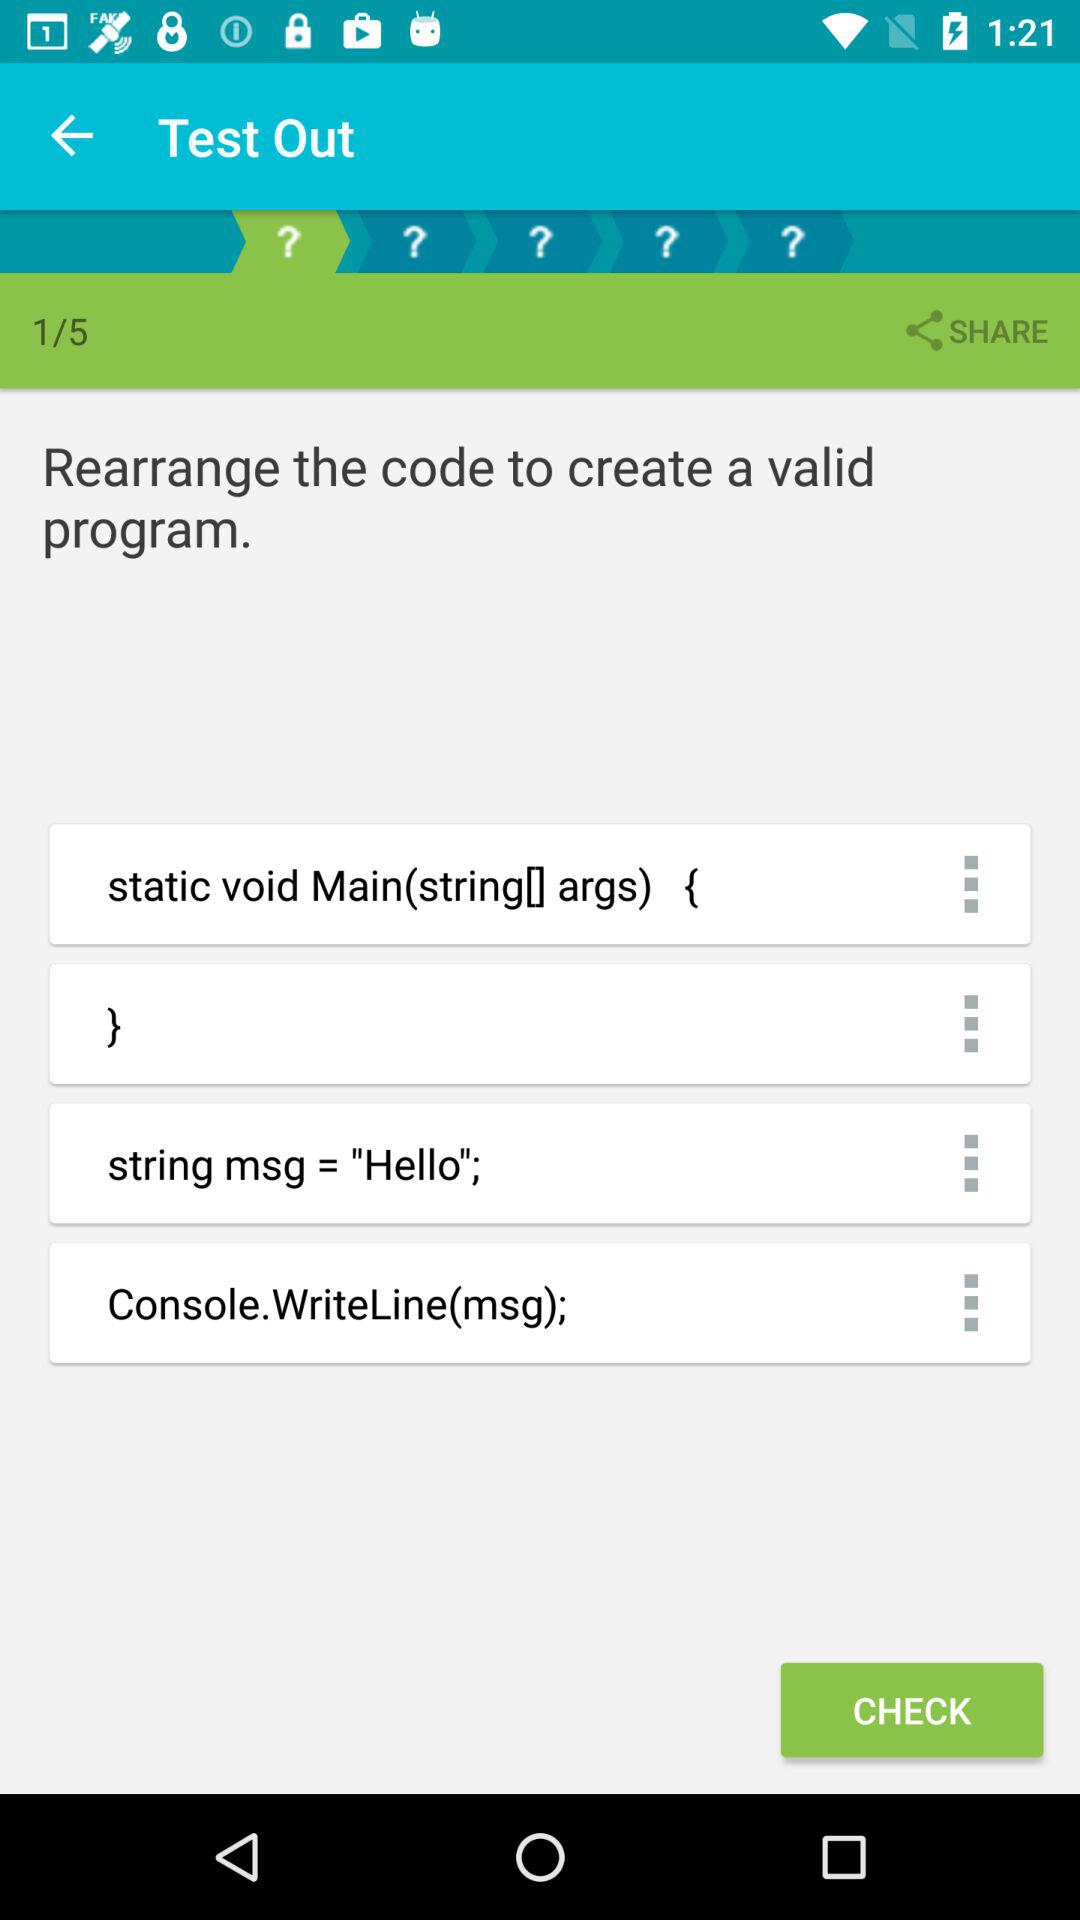How many question marks are on the turquoise and white striped background?
Answer the question using a single word or phrase. 5 